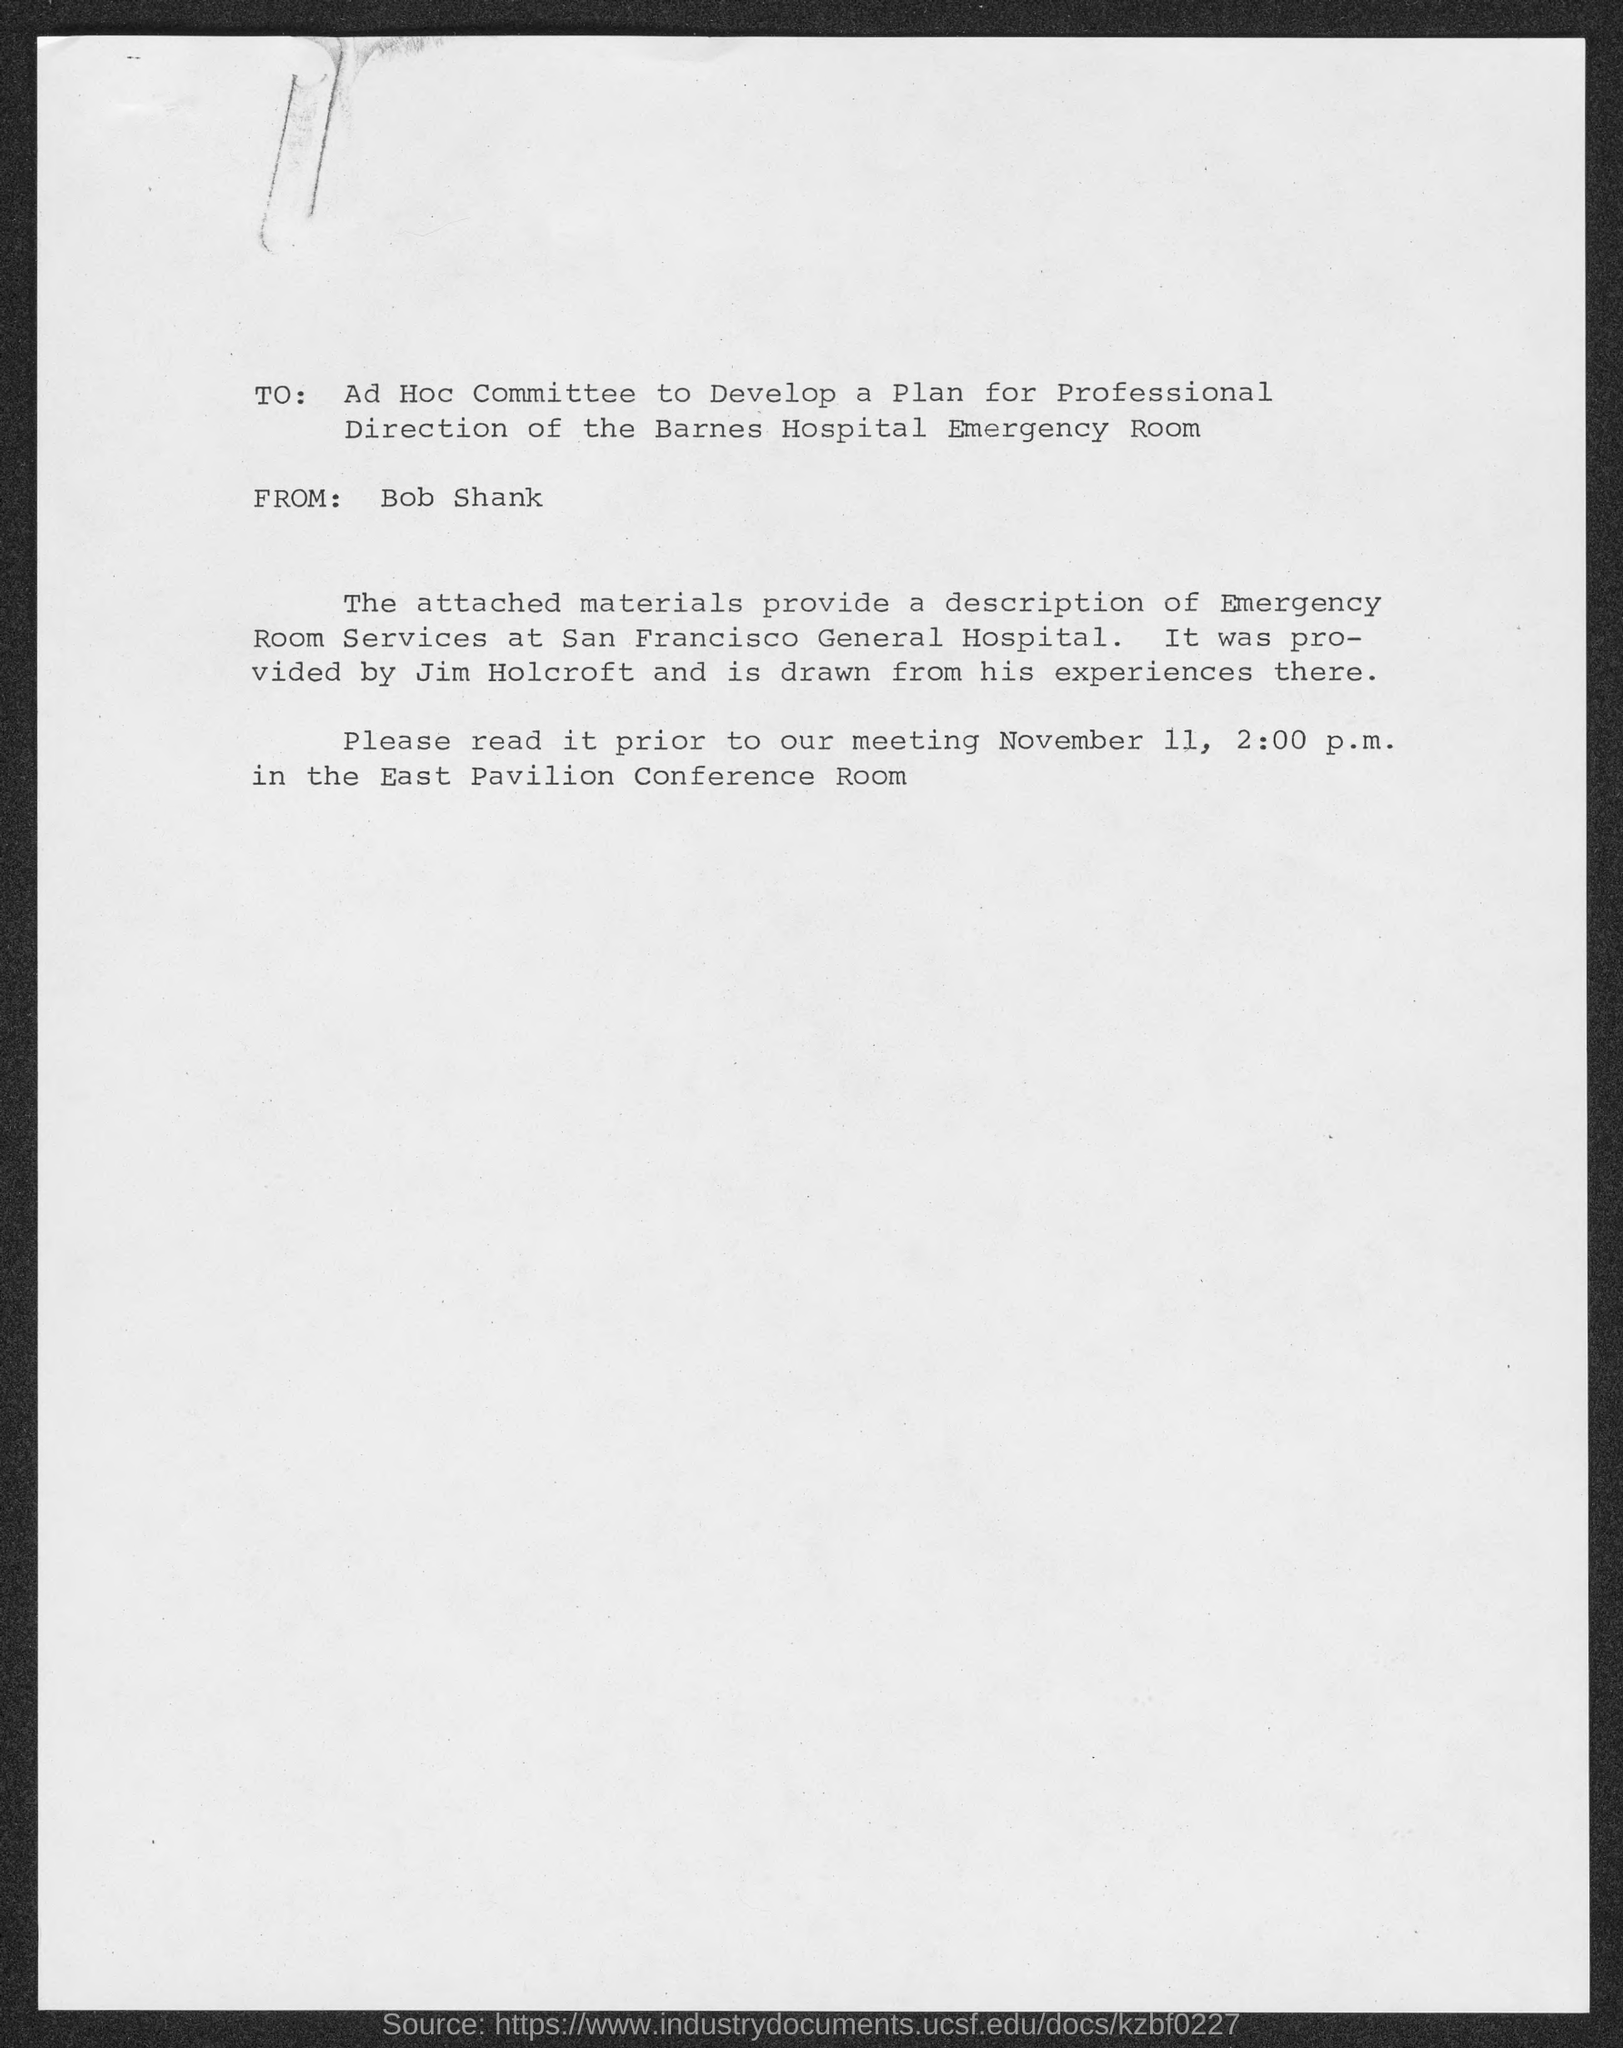Who has sent this message?
Give a very brief answer. Bob Shank. "Description of Emergency Room Services" at which HOSPITAL is mentioned?
Your response must be concise. SAN FRANCISCO GENERAL HOSPITAL. "Description of Emergency Room Services at San Francisco General Hospital" is provided by whom?
Give a very brief answer. Jim Holcroft. Where will be the meeting held?
Offer a terse response. East Pavilion Conference Room. Meeting will be held at what time?
Your answer should be compact. 2:00  p.m. 